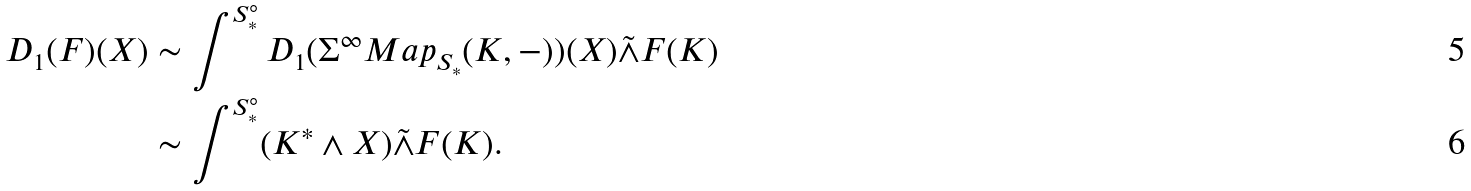<formula> <loc_0><loc_0><loc_500><loc_500>D _ { 1 } ( F ) ( X ) & \sim \int ^ { S ^ { \circ } _ { * } } D _ { 1 } ( \Sigma ^ { \infty } M a p _ { S _ { * } } ( K , - ) ) ( X ) \tilde { \wedge } F ( K ) \\ & \sim \int ^ { S ^ { \circ } _ { * } } ( K ^ { * } \wedge X ) \tilde { \wedge } F ( K ) .</formula> 